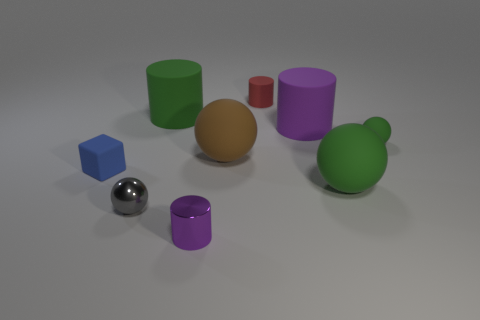Subtract all small purple cylinders. How many cylinders are left? 3 Subtract all cyan cubes. How many green spheres are left? 2 Add 1 small gray matte blocks. How many objects exist? 10 Subtract all brown balls. How many balls are left? 3 Subtract all cubes. How many objects are left? 8 Subtract all red cylinders. Subtract all red balls. How many cylinders are left? 3 Add 8 small purple shiny things. How many small purple shiny things are left? 9 Add 5 red rubber cylinders. How many red rubber cylinders exist? 6 Subtract 2 purple cylinders. How many objects are left? 7 Subtract all small gray rubber blocks. Subtract all rubber objects. How many objects are left? 2 